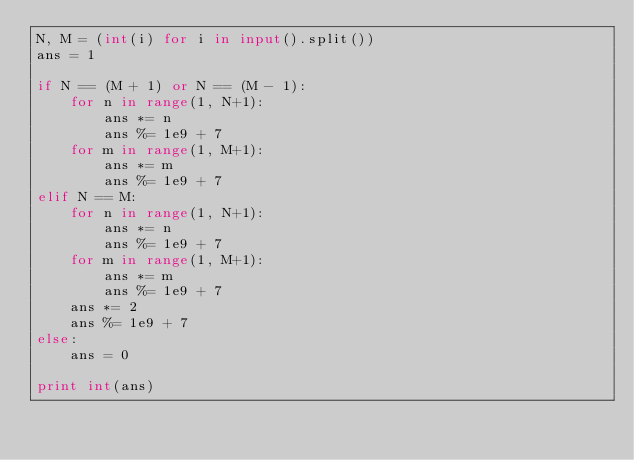Convert code to text. <code><loc_0><loc_0><loc_500><loc_500><_Python_>N, M = (int(i) for i in input().split())
ans = 1

if N == (M + 1) or N == (M - 1):
    for n in range(1, N+1):
        ans *= n
        ans %= 1e9 + 7
    for m in range(1, M+1):
        ans *= m
        ans %= 1e9 + 7
elif N == M:
    for n in range(1, N+1):
        ans *= n
        ans %= 1e9 + 7
    for m in range(1, M+1):
        ans *= m
        ans %= 1e9 + 7
    ans *= 2
    ans %= 1e9 + 7
else:
    ans = 0

print int(ans)</code> 